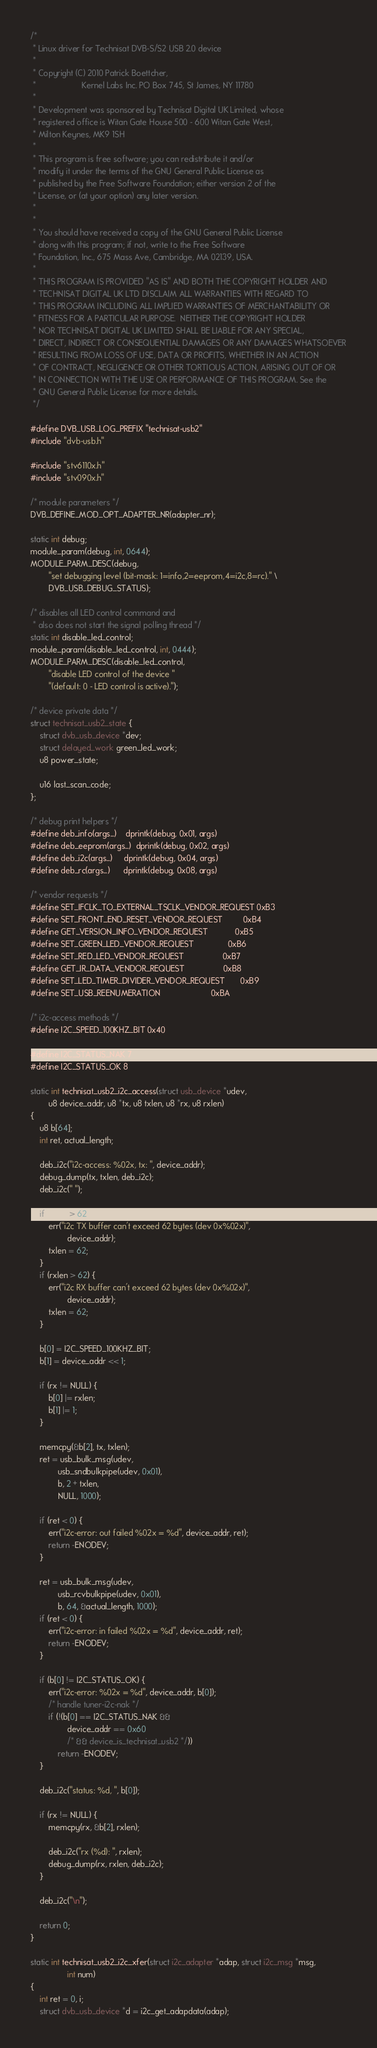<code> <loc_0><loc_0><loc_500><loc_500><_C_>/*
 * Linux driver for Technisat DVB-S/S2 USB 2.0 device
 *
 * Copyright (C) 2010 Patrick Boettcher,
 *                    Kernel Labs Inc. PO Box 745, St James, NY 11780
 *
 * Development was sponsored by Technisat Digital UK Limited, whose
 * registered office is Witan Gate House 500 - 600 Witan Gate West,
 * Milton Keynes, MK9 1SH
 *
 * This program is free software; you can redistribute it and/or
 * modify it under the terms of the GNU General Public License as
 * published by the Free Software Foundation; either version 2 of the
 * License, or (at your option) any later version.
 *
 *
 * You should have received a copy of the GNU General Public License
 * along with this program; if not, write to the Free Software
 * Foundation, Inc., 675 Mass Ave, Cambridge, MA 02139, USA.
 *
 * THIS PROGRAM IS PROVIDED "AS IS" AND BOTH THE COPYRIGHT HOLDER AND
 * TECHNISAT DIGITAL UK LTD DISCLAIM ALL WARRANTIES WITH REGARD TO
 * THIS PROGRAM INCLUDING ALL IMPLIED WARRANTIES OF MERCHANTABILITY OR
 * FITNESS FOR A PARTICULAR PURPOSE.  NEITHER THE COPYRIGHT HOLDER
 * NOR TECHNISAT DIGITAL UK LIMITED SHALL BE LIABLE FOR ANY SPECIAL,
 * DIRECT, INDIRECT OR CONSEQUENTIAL DAMAGES OR ANY DAMAGES WHATSOEVER
 * RESULTING FROM LOSS OF USE, DATA OR PROFITS, WHETHER IN AN ACTION
 * OF CONTRACT, NEGLIGENCE OR OTHER TORTIOUS ACTION, ARISING OUT OF OR
 * IN CONNECTION WITH THE USE OR PERFORMANCE OF THIS PROGRAM. See the
 * GNU General Public License for more details.
 */

#define DVB_USB_LOG_PREFIX "technisat-usb2"
#include "dvb-usb.h"

#include "stv6110x.h"
#include "stv090x.h"

/* module parameters */
DVB_DEFINE_MOD_OPT_ADAPTER_NR(adapter_nr);

static int debug;
module_param(debug, int, 0644);
MODULE_PARM_DESC(debug,
		"set debugging level (bit-mask: 1=info,2=eeprom,4=i2c,8=rc)." \
		DVB_USB_DEBUG_STATUS);

/* disables all LED control command and
 * also does not start the signal polling thread */
static int disable_led_control;
module_param(disable_led_control, int, 0444);
MODULE_PARM_DESC(disable_led_control,
		"disable LED control of the device "
		"(default: 0 - LED control is active).");

/* device private data */
struct technisat_usb2_state {
	struct dvb_usb_device *dev;
	struct delayed_work green_led_work;
	u8 power_state;

	u16 last_scan_code;
};

/* debug print helpers */
#define deb_info(args...)    dprintk(debug, 0x01, args)
#define deb_eeprom(args...)  dprintk(debug, 0x02, args)
#define deb_i2c(args...)     dprintk(debug, 0x04, args)
#define deb_rc(args...)      dprintk(debug, 0x08, args)

/* vendor requests */
#define SET_IFCLK_TO_EXTERNAL_TSCLK_VENDOR_REQUEST 0xB3
#define SET_FRONT_END_RESET_VENDOR_REQUEST         0xB4
#define GET_VERSION_INFO_VENDOR_REQUEST            0xB5
#define SET_GREEN_LED_VENDOR_REQUEST               0xB6
#define SET_RED_LED_VENDOR_REQUEST                 0xB7
#define GET_IR_DATA_VENDOR_REQUEST                 0xB8
#define SET_LED_TIMER_DIVIDER_VENDOR_REQUEST       0xB9
#define SET_USB_REENUMERATION                      0xBA

/* i2c-access methods */
#define I2C_SPEED_100KHZ_BIT 0x40

#define I2C_STATUS_NAK 7
#define I2C_STATUS_OK 8

static int technisat_usb2_i2c_access(struct usb_device *udev,
		u8 device_addr, u8 *tx, u8 txlen, u8 *rx, u8 rxlen)
{
	u8 b[64];
	int ret, actual_length;

	deb_i2c("i2c-access: %02x, tx: ", device_addr);
	debug_dump(tx, txlen, deb_i2c);
	deb_i2c(" ");

	if (txlen > 62) {
		err("i2c TX buffer can't exceed 62 bytes (dev 0x%02x)",
				device_addr);
		txlen = 62;
	}
	if (rxlen > 62) {
		err("i2c RX buffer can't exceed 62 bytes (dev 0x%02x)",
				device_addr);
		txlen = 62;
	}

	b[0] = I2C_SPEED_100KHZ_BIT;
	b[1] = device_addr << 1;

	if (rx != NULL) {
		b[0] |= rxlen;
		b[1] |= 1;
	}

	memcpy(&b[2], tx, txlen);
	ret = usb_bulk_msg(udev,
			usb_sndbulkpipe(udev, 0x01),
			b, 2 + txlen,
			NULL, 1000);

	if (ret < 0) {
		err("i2c-error: out failed %02x = %d", device_addr, ret);
		return -ENODEV;
	}

	ret = usb_bulk_msg(udev,
			usb_rcvbulkpipe(udev, 0x01),
			b, 64, &actual_length, 1000);
	if (ret < 0) {
		err("i2c-error: in failed %02x = %d", device_addr, ret);
		return -ENODEV;
	}

	if (b[0] != I2C_STATUS_OK) {
		err("i2c-error: %02x = %d", device_addr, b[0]);
		/* handle tuner-i2c-nak */
		if (!(b[0] == I2C_STATUS_NAK &&
				device_addr == 0x60
				/* && device_is_technisat_usb2 */))
			return -ENODEV;
	}

	deb_i2c("status: %d, ", b[0]);

	if (rx != NULL) {
		memcpy(rx, &b[2], rxlen);

		deb_i2c("rx (%d): ", rxlen);
		debug_dump(rx, rxlen, deb_i2c);
	}

	deb_i2c("\n");

	return 0;
}

static int technisat_usb2_i2c_xfer(struct i2c_adapter *adap, struct i2c_msg *msg,
				int num)
{
	int ret = 0, i;
	struct dvb_usb_device *d = i2c_get_adapdata(adap);
</code> 